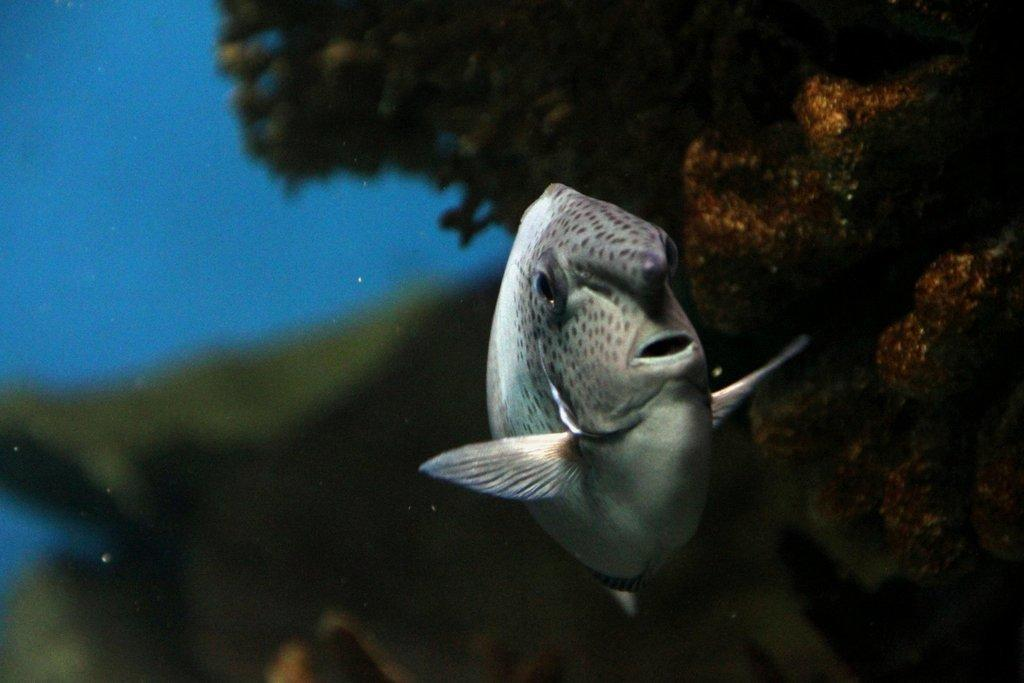What type of animal is in the image? There is a fish in the image. Where is the fish located? The fish is in water. What type of quill is the fish using to write in the image? There is no quill present in the image, and fish do not have the ability to write. 